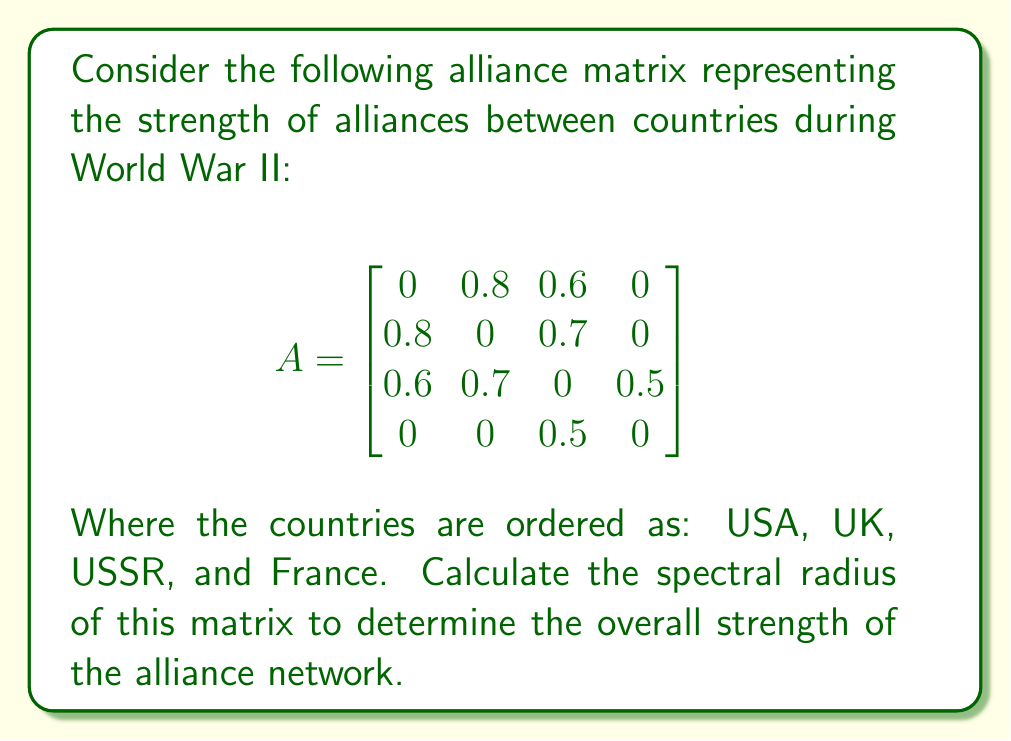What is the answer to this math problem? To find the spectral radius of matrix $A$, we need to follow these steps:

1) First, we need to find the characteristic polynomial of $A$:
   $det(A - \lambda I) = 0$

2) Expanding this determinant:
   $$\begin{vmatrix}
   -\lambda & 0.8 & 0.6 & 0 \\
   0.8 & -\lambda & 0.7 & 0 \\
   0.6 & 0.7 & -\lambda & 0.5 \\
   0 & 0 & 0.5 & -\lambda
   \end{vmatrix} = 0$$

3) This expands to:
   $\lambda^4 - 1.49\lambda^2 - 0.7\lambda + 0.49 = 0$

4) This is a 4th degree polynomial. We can solve it numerically to find its roots.

5) The roots (eigenvalues) are approximately:
   $\lambda_1 \approx 1.4142$
   $\lambda_2 \approx -0.7071$
   $\lambda_3 \approx 0.5000$
   $\lambda_4 \approx -0.5000$

6) The spectral radius is the maximum absolute value of these eigenvalues.

7) Therefore, the spectral radius is approximately 1.4142.

This value represents the overall strength of the alliance network. A higher value indicates a stronger, more interconnected alliance system.
Answer: $\rho(A) \approx 1.4142$ 